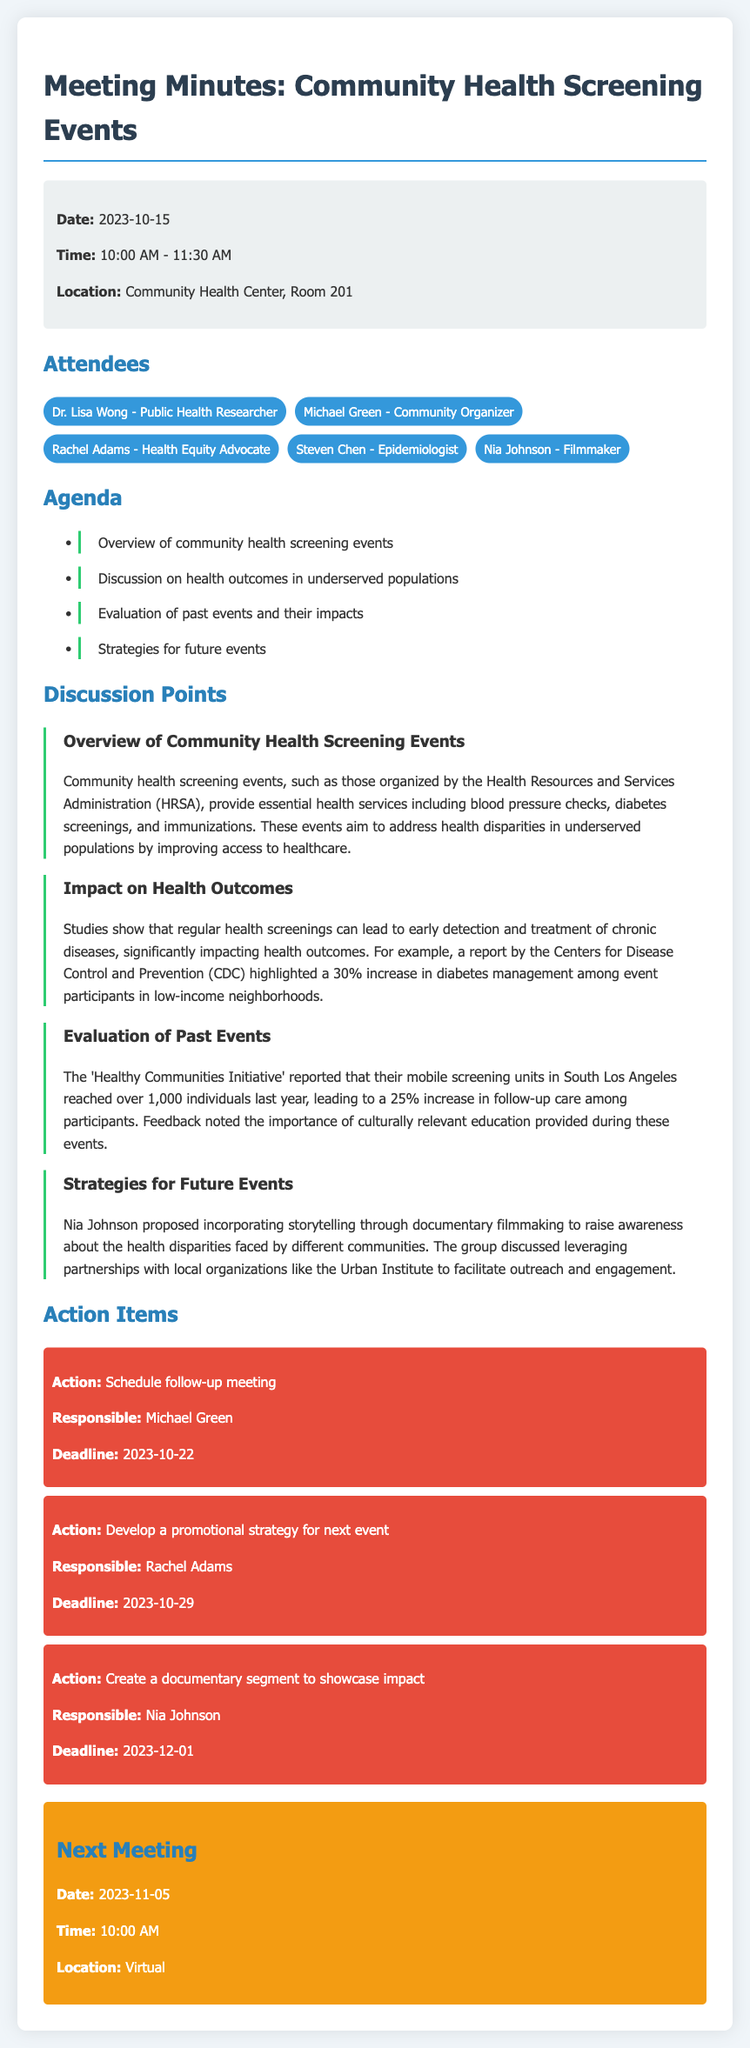What is the date of the meeting? The meeting date is explicitly mentioned in the document as 2023-10-15.
Answer: 2023-10-15 Who is responsible for developing the promotional strategy for the next event? The document lists Rachel Adams as responsible for developing the promotional strategy for the next event.
Answer: Rachel Adams What was the increase in diabetes management among event participants in low-income neighborhoods? The document states there was a 30% increase in diabetes management among participants.
Answer: 30% What community was highlighted for the mobile screening units? The document refers to South Los Angeles as the location for the mobile screening units.
Answer: South Los Angeles What is the deadline for creating a documentary segment to showcase impact? The deadline for creating the documentary segment is specified as 2023-12-01 in the document.
Answer: 2023-12-01 What type of events are discussed in the meeting? The document discusses community health screening events that aim to provide essential health services.
Answer: community health screening events How many individuals did the 'Healthy Communities Initiative' reach last year? The document indicates that the initiative reached over 1,000 individuals last year.
Answer: over 1,000 What was one of the proposed strategies for future events? Nia Johnson proposed incorporating storytelling through documentary filmmaking to raise awareness about health disparities.
Answer: storytelling through documentary filmmaking 